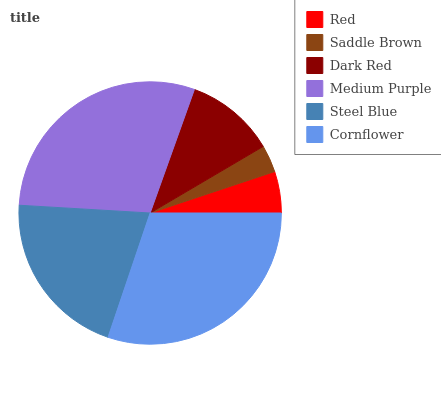Is Saddle Brown the minimum?
Answer yes or no. Yes. Is Cornflower the maximum?
Answer yes or no. Yes. Is Dark Red the minimum?
Answer yes or no. No. Is Dark Red the maximum?
Answer yes or no. No. Is Dark Red greater than Saddle Brown?
Answer yes or no. Yes. Is Saddle Brown less than Dark Red?
Answer yes or no. Yes. Is Saddle Brown greater than Dark Red?
Answer yes or no. No. Is Dark Red less than Saddle Brown?
Answer yes or no. No. Is Steel Blue the high median?
Answer yes or no. Yes. Is Dark Red the low median?
Answer yes or no. Yes. Is Medium Purple the high median?
Answer yes or no. No. Is Medium Purple the low median?
Answer yes or no. No. 